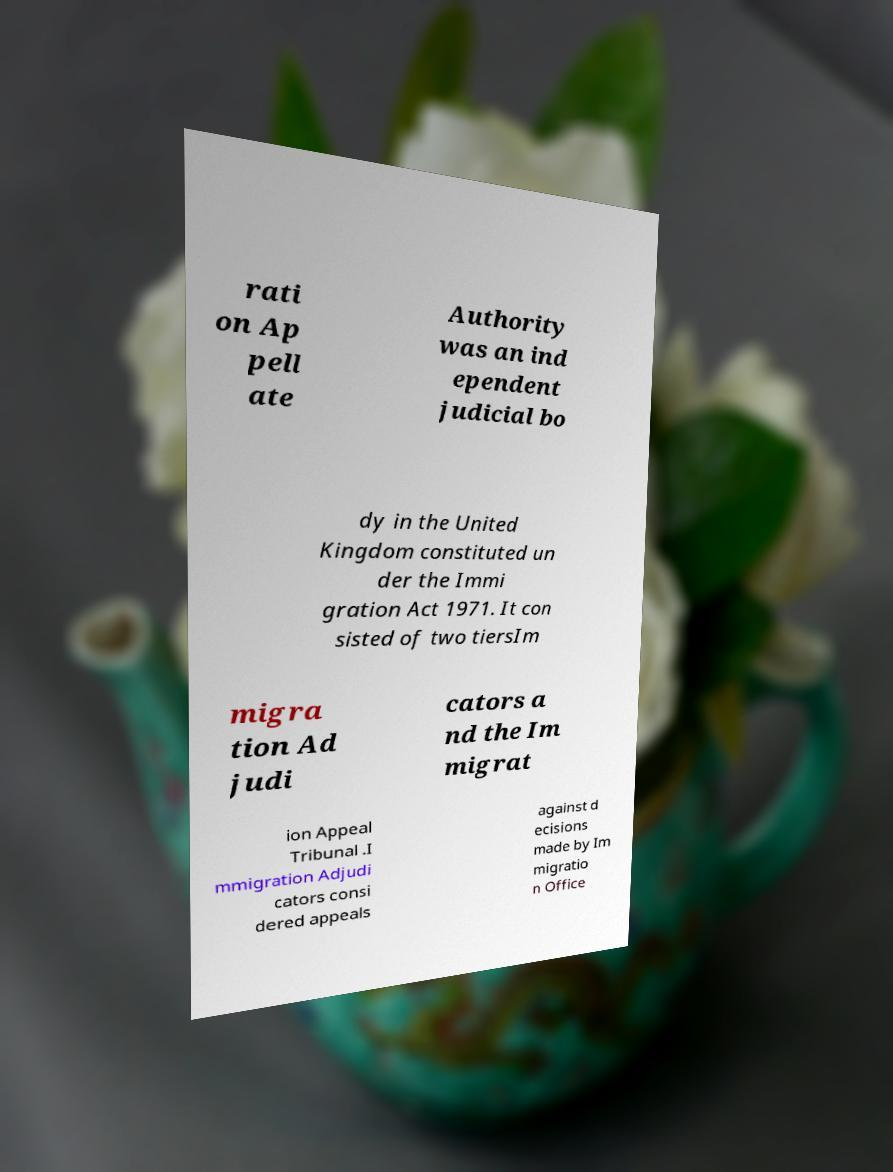Could you extract and type out the text from this image? rati on Ap pell ate Authority was an ind ependent judicial bo dy in the United Kingdom constituted un der the Immi gration Act 1971. It con sisted of two tiersIm migra tion Ad judi cators a nd the Im migrat ion Appeal Tribunal .I mmigration Adjudi cators consi dered appeals against d ecisions made by Im migratio n Office 